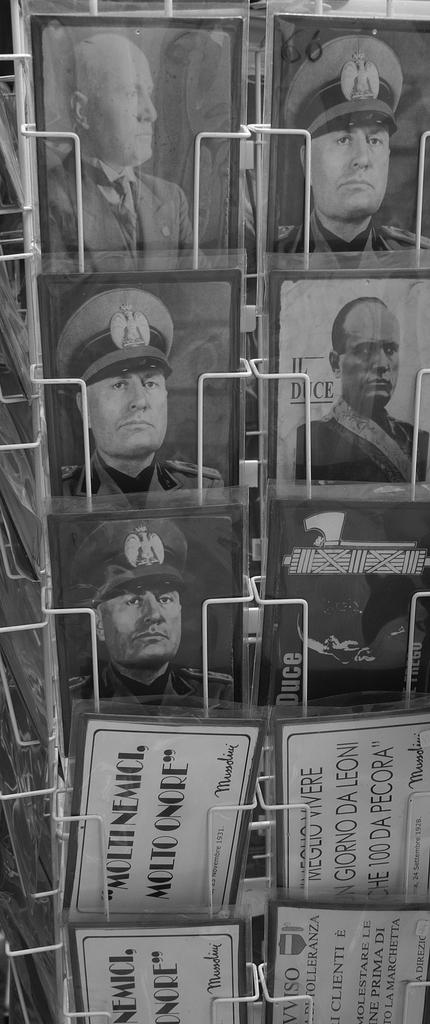<image>
Create a compact narrative representing the image presented. A number of postcards, one of which says Moltinemci, Moltoonore. 